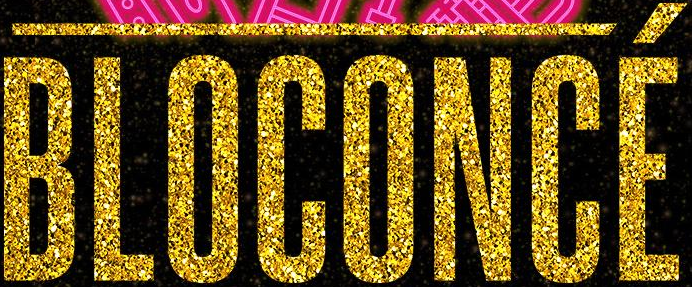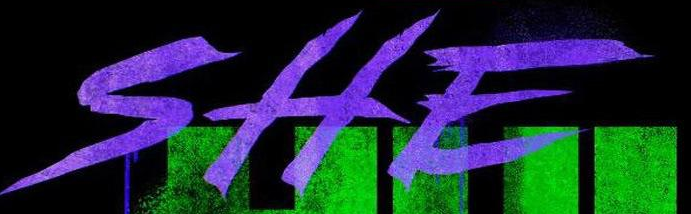What text appears in these images from left to right, separated by a semicolon? BLOCONCÉ; SHE 